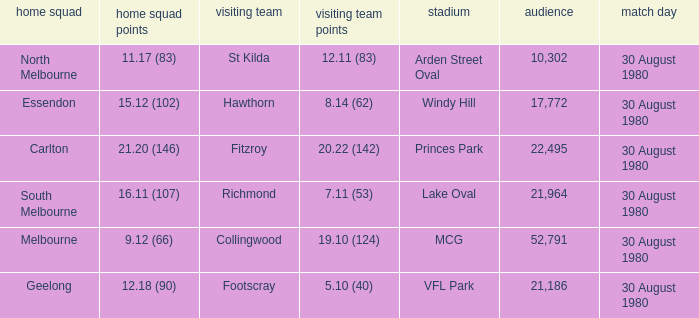What is the home team score at lake oval? 16.11 (107). 